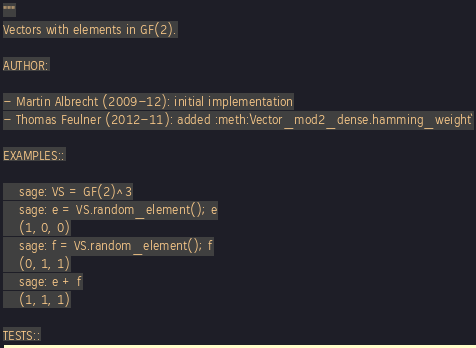Convert code to text. <code><loc_0><loc_0><loc_500><loc_500><_Cython_>"""
Vectors with elements in GF(2).

AUTHOR:

- Martin Albrecht (2009-12): initial implementation
- Thomas Feulner (2012-11): added :meth:`Vector_mod2_dense.hamming_weight`

EXAMPLES::

    sage: VS = GF(2)^3
    sage: e = VS.random_element(); e
    (1, 0, 0)
    sage: f = VS.random_element(); f
    (0, 1, 1)
    sage: e + f
    (1, 1, 1)

TESTS::
</code> 